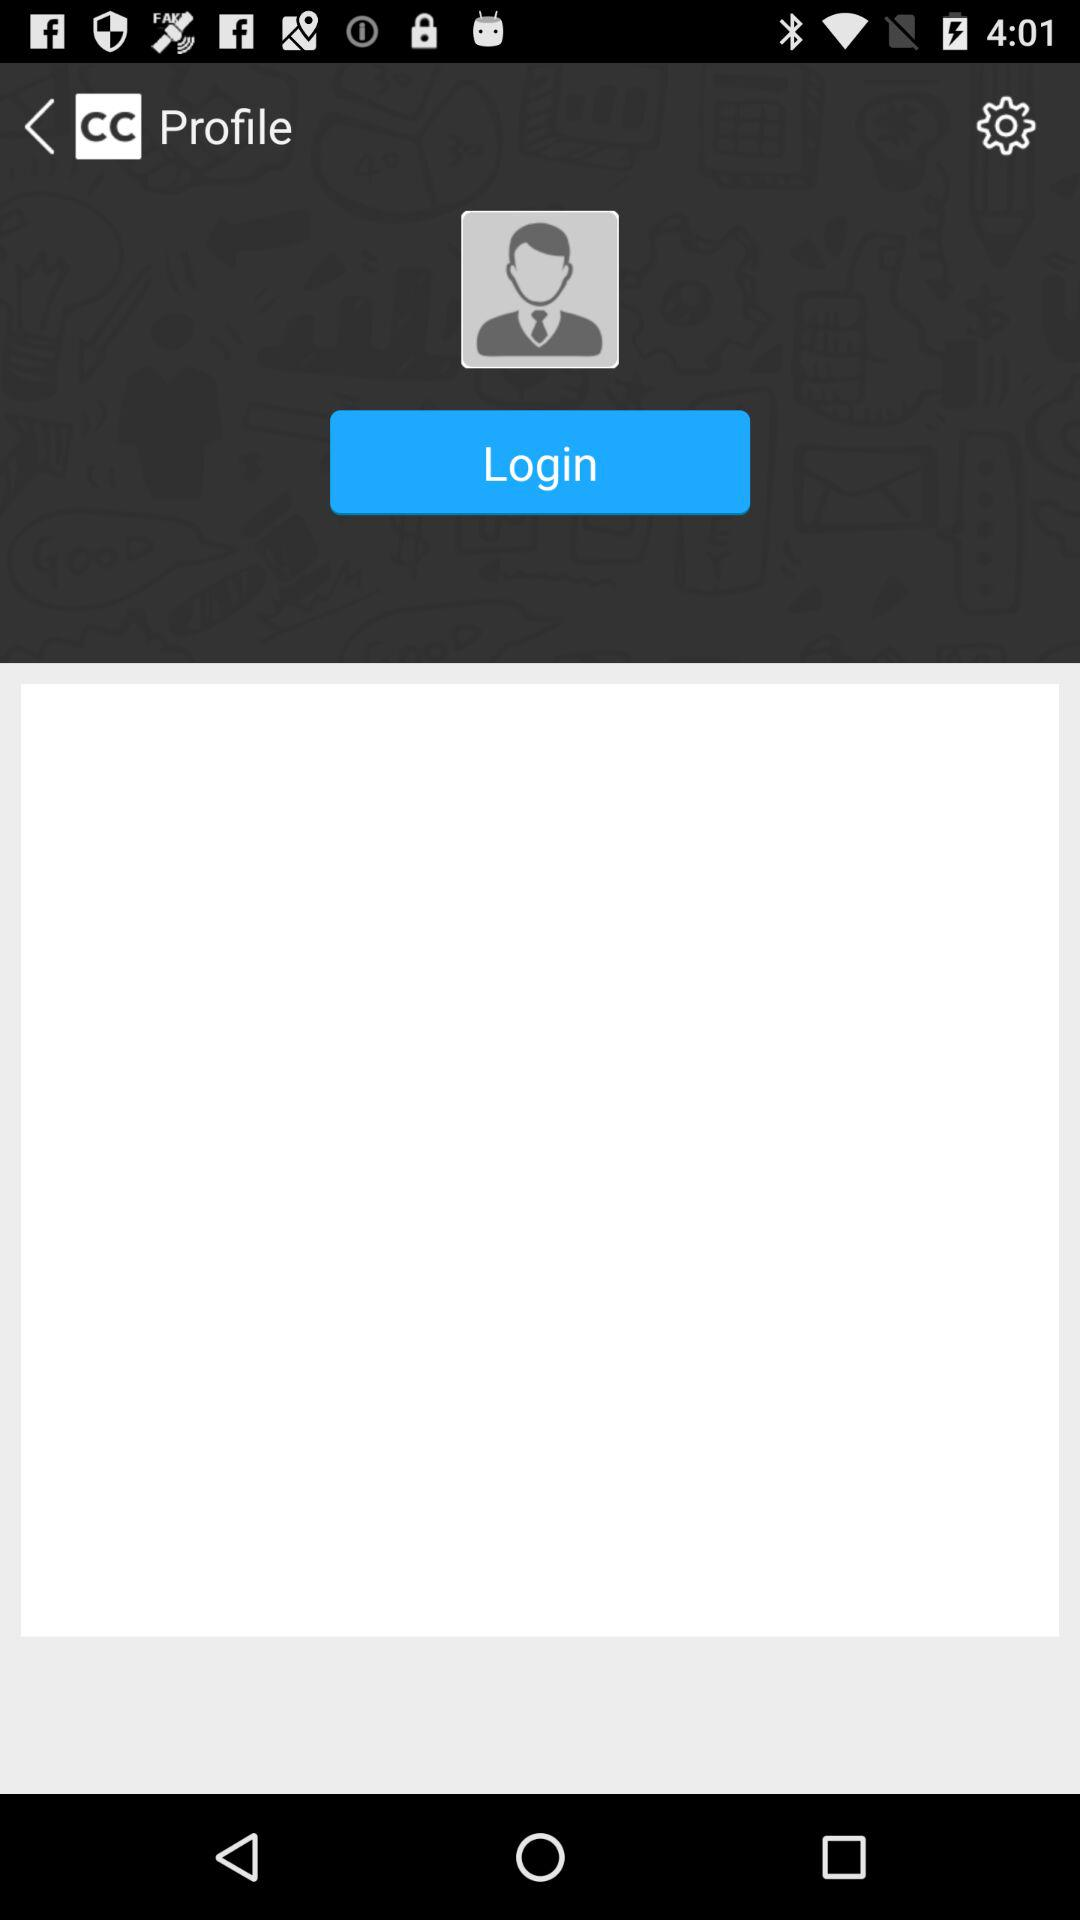What is the name of the application? The name of the application is "Creative Commons". 